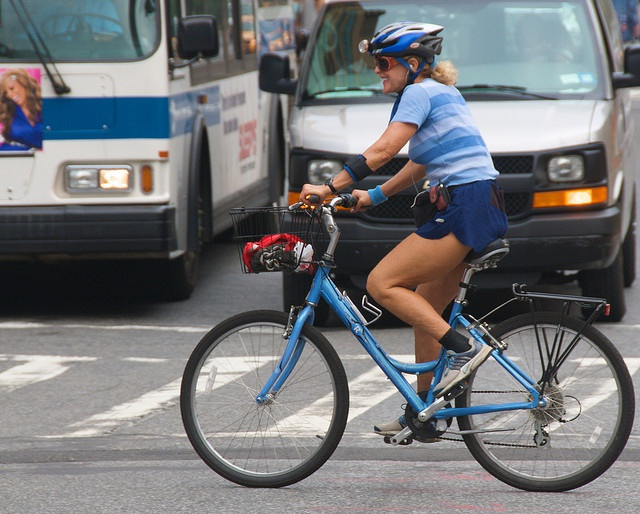Describe the objects in this image and their specific colors. I can see bus in teal, black, gray, darkgray, and lightgray tones, bicycle in teal, darkgray, black, gray, and lightgray tones, car in teal, black, darkgray, lightgray, and gray tones, people in teal, black, navy, brown, and maroon tones, and people in teal and darkgray tones in this image. 